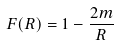Convert formula to latex. <formula><loc_0><loc_0><loc_500><loc_500>F ( R ) = 1 - \frac { 2 m } { R }</formula> 